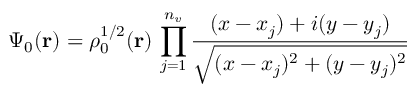<formula> <loc_0><loc_0><loc_500><loc_500>\Psi _ { 0 } ( r ) = \rho _ { 0 } ^ { 1 / 2 } ( r ) \, \prod _ { j = 1 } ^ { n _ { v } } { \frac { ( x - x _ { j } ) + i ( y - y _ { j } ) } { \sqrt { ( x - x _ { j } ) ^ { 2 } + ( y - y _ { j } ) ^ { 2 } } } }</formula> 